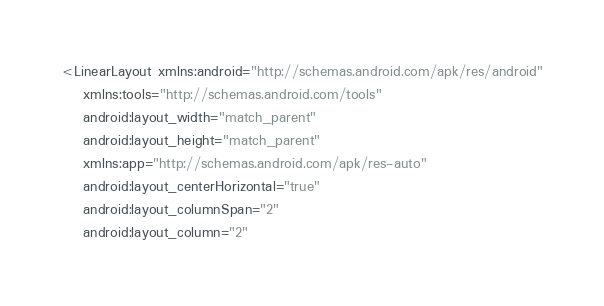Convert code to text. <code><loc_0><loc_0><loc_500><loc_500><_XML_><LinearLayout xmlns:android="http://schemas.android.com/apk/res/android"
    xmlns:tools="http://schemas.android.com/tools"
    android:layout_width="match_parent"
    android:layout_height="match_parent"
    xmlns:app="http://schemas.android.com/apk/res-auto"
    android:layout_centerHorizontal="true"
    android:layout_columnSpan="2"
    android:layout_column="2"</code> 